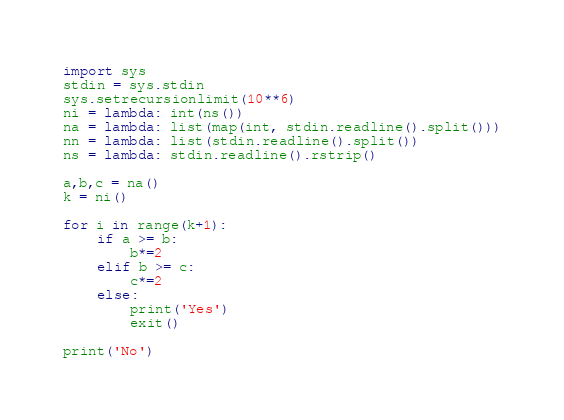<code> <loc_0><loc_0><loc_500><loc_500><_Python_>import sys
stdin = sys.stdin
sys.setrecursionlimit(10**6)
ni = lambda: int(ns())
na = lambda: list(map(int, stdin.readline().split()))
nn = lambda: list(stdin.readline().split())
ns = lambda: stdin.readline().rstrip()

a,b,c = na()
k = ni()

for i in range(k+1):
    if a >= b:
        b*=2
    elif b >= c:
        c*=2
    else:
        print('Yes')
        exit()

print('No')</code> 